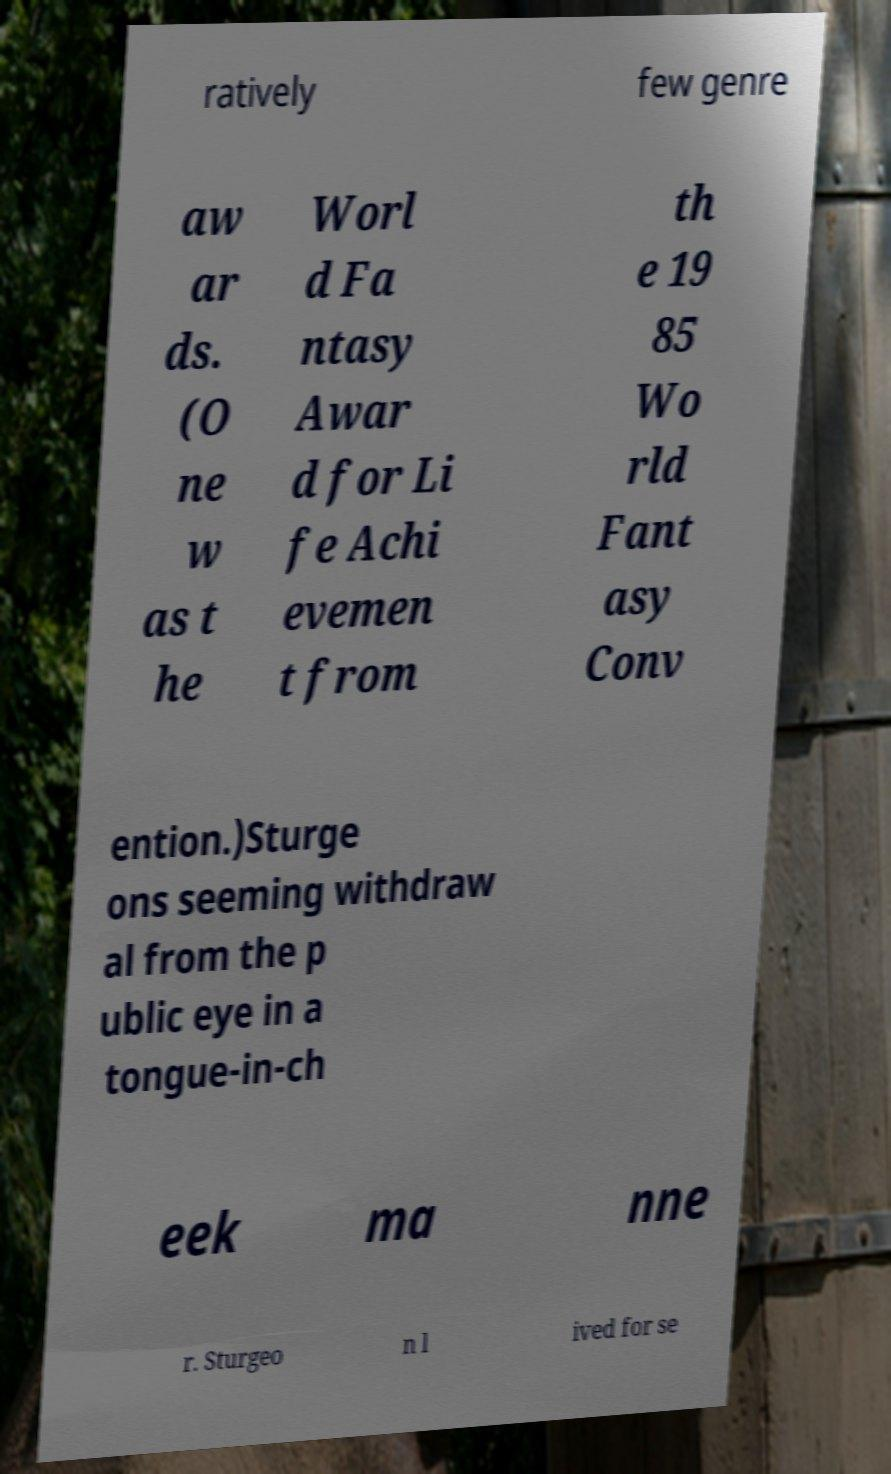Can you accurately transcribe the text from the provided image for me? ratively few genre aw ar ds. (O ne w as t he Worl d Fa ntasy Awar d for Li fe Achi evemen t from th e 19 85 Wo rld Fant asy Conv ention.)Sturge ons seeming withdraw al from the p ublic eye in a tongue-in-ch eek ma nne r. Sturgeo n l ived for se 